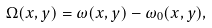Convert formula to latex. <formula><loc_0><loc_0><loc_500><loc_500>\Omega ( x , y ) = \omega ( x , y ) - \omega _ { 0 } ( x , y ) ,</formula> 